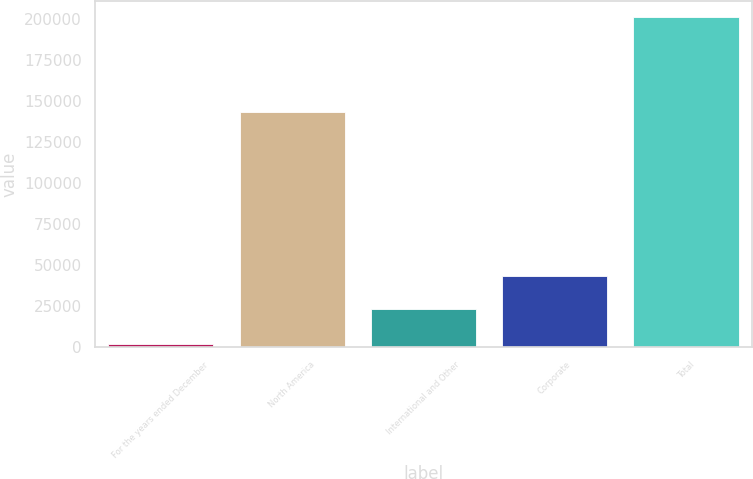<chart> <loc_0><loc_0><loc_500><loc_500><bar_chart><fcel>For the years ended December<fcel>North America<fcel>International and Other<fcel>Corporate<fcel>Total<nl><fcel>2013<fcel>143640<fcel>23461<fcel>43363<fcel>201033<nl></chart> 